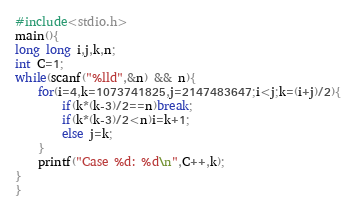Convert code to text. <code><loc_0><loc_0><loc_500><loc_500><_C++_>#include<stdio.h>
main(){
long long i,j,k,n;
int C=1;
while(scanf("%lld",&n) && n){
    for(i=4,k=1073741825,j=2147483647;i<j;k=(i+j)/2){
        if(k*(k-3)/2==n)break;
        if(k*(k-3)/2<n)i=k+1;
        else j=k;
    }
    printf("Case %d: %d\n",C++,k);
}
}
</code> 